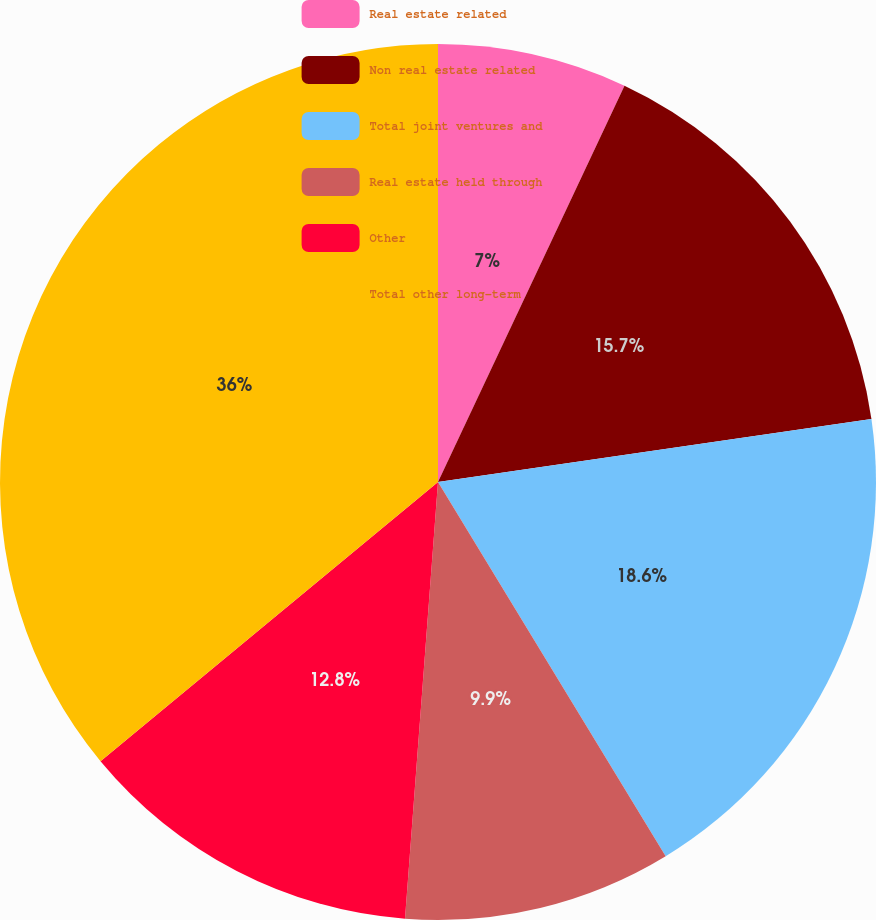Convert chart. <chart><loc_0><loc_0><loc_500><loc_500><pie_chart><fcel>Real estate related<fcel>Non real estate related<fcel>Total joint ventures and<fcel>Real estate held through<fcel>Other<fcel>Total other long-term<nl><fcel>7.0%<fcel>15.7%<fcel>18.6%<fcel>9.9%<fcel>12.8%<fcel>36.0%<nl></chart> 